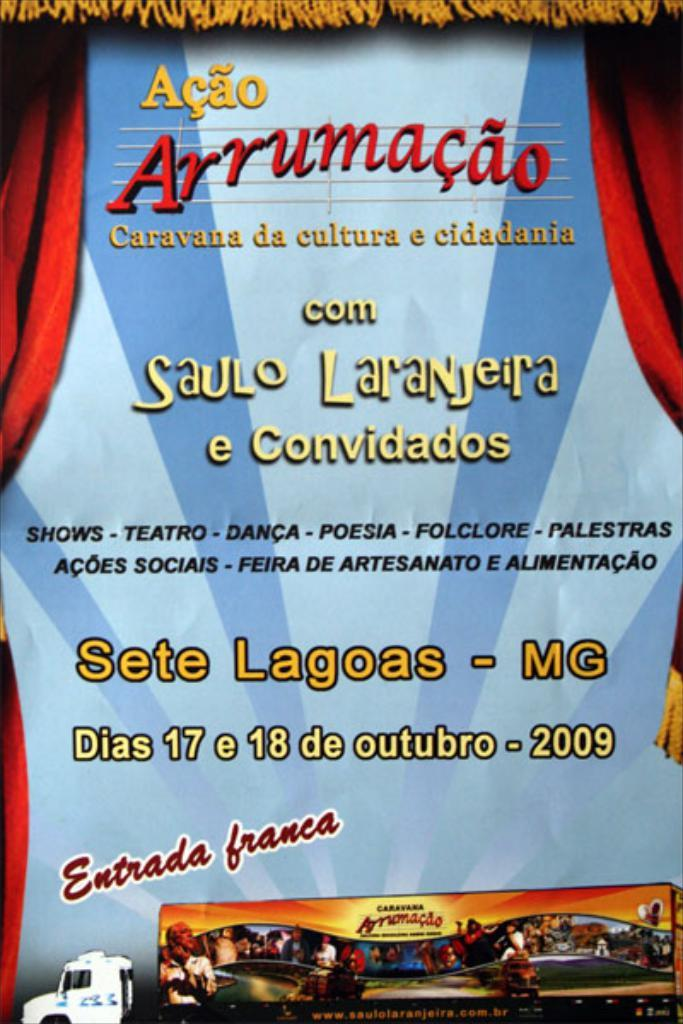<image>
Write a terse but informative summary of the picture. A poster that says Acao Arrumacao comSaulo Laranjeira on it. 